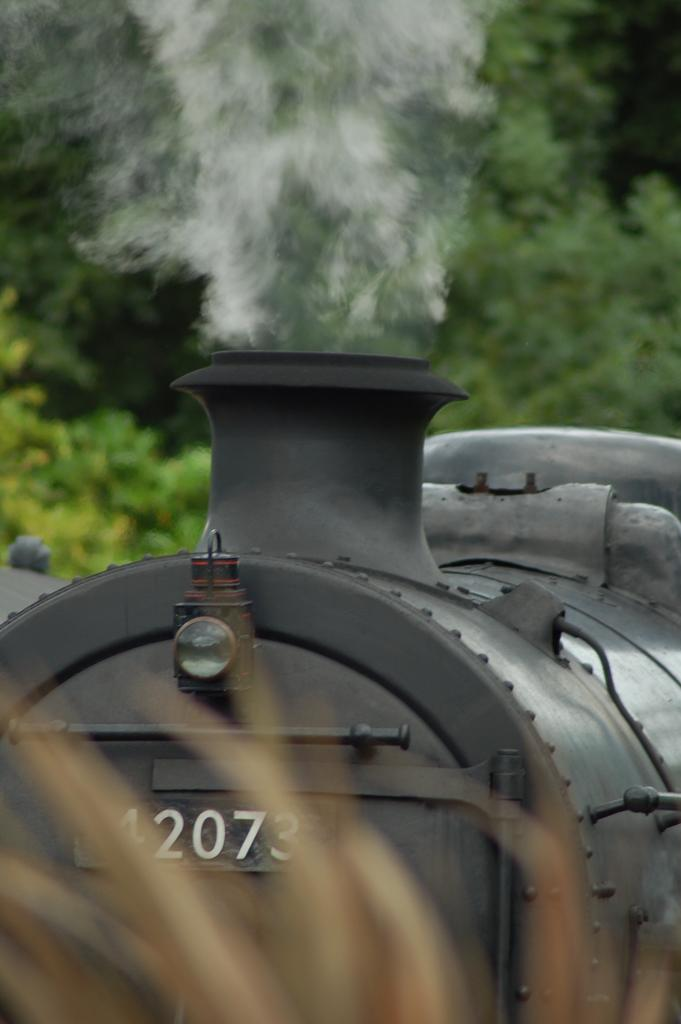What type of surface is at the bottom of the image? There is grass at the bottom of the image. What can be seen in the background of the image? There is a black color train in the background, and there are trees as well. What color are the numbers on the train? The train has white color numbers on it. What is the train doing in the image? The train is emitting smoke in the image. What type of music can be heard coming from the grass in the image? There is no music present in the image; it only features grass, a train, and trees. 